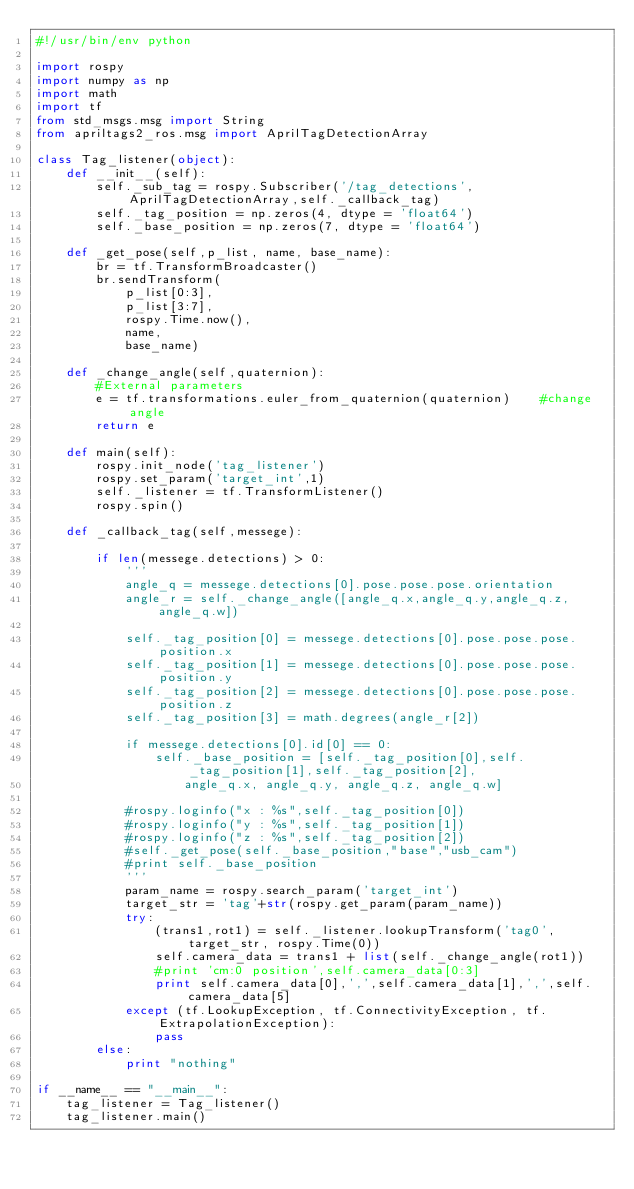<code> <loc_0><loc_0><loc_500><loc_500><_Python_>#!/usr/bin/env python

import rospy
import numpy as np
import math
import tf
from std_msgs.msg import String
from apriltags2_ros.msg import AprilTagDetectionArray

class Tag_listener(object):
    def __init__(self):
        self._sub_tag = rospy.Subscriber('/tag_detections',AprilTagDetectionArray,self._callback_tag)
        self._tag_position = np.zeros(4, dtype = 'float64')
        self._base_position = np.zeros(7, dtype = 'float64')

    def _get_pose(self,p_list, name, base_name):
        br = tf.TransformBroadcaster()
        br.sendTransform(
            p_list[0:3],
            p_list[3:7],
            rospy.Time.now(),
            name,
            base_name)

    def _change_angle(self,quaternion):
        #External parameters
        e = tf.transformations.euler_from_quaternion(quaternion)    #change angle
        return e

    def main(self):
        rospy.init_node('tag_listener')
        rospy.set_param('target_int',1)
        self._listener = tf.TransformListener()
        rospy.spin()

    def _callback_tag(self,messege):

        if len(messege.detections) > 0:
            '''
            angle_q = messege.detections[0].pose.pose.pose.orientation
            angle_r = self._change_angle([angle_q.x,angle_q.y,angle_q.z,angle_q.w])

            self._tag_position[0] = messege.detections[0].pose.pose.pose.position.x
            self._tag_position[1] = messege.detections[0].pose.pose.pose.position.y
            self._tag_position[2] = messege.detections[0].pose.pose.pose.position.z
            self._tag_position[3] = math.degrees(angle_r[2])

            if messege.detections[0].id[0] == 0:
                self._base_position = [self._tag_position[0],self._tag_position[1],self._tag_position[2],
                    angle_q.x, angle_q.y, angle_q.z, angle_q.w]

            #rospy.loginfo("x : %s",self._tag_position[0])
            #rospy.loginfo("y : %s",self._tag_position[1])
            #rospy.loginfo("z : %s",self._tag_position[2])
            #self._get_pose(self._base_position,"base","usb_cam")
            #print self._base_position
            '''
            param_name = rospy.search_param('target_int')
            target_str = 'tag'+str(rospy.get_param(param_name))
            try:
                (trans1,rot1) = self._listener.lookupTransform('tag0', target_str, rospy.Time(0))
                self.camera_data = trans1 + list(self._change_angle(rot1))
                #print 'cm:0 position',self.camera_data[0:3]
                print self.camera_data[0],',',self.camera_data[1],',',self.camera_data[5]
            except (tf.LookupException, tf.ConnectivityException, tf.ExtrapolationException):
                pass
        else:
            print "nothing"

if __name__ == "__main__":
    tag_listener = Tag_listener()
    tag_listener.main()
</code> 